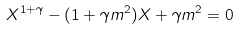<formula> <loc_0><loc_0><loc_500><loc_500>X ^ { 1 + \gamma } - ( 1 + \gamma m ^ { 2 } ) X + \gamma m ^ { 2 } = 0</formula> 